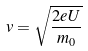<formula> <loc_0><loc_0><loc_500><loc_500>v = \sqrt { \frac { 2 e U } { m _ { 0 } } }</formula> 